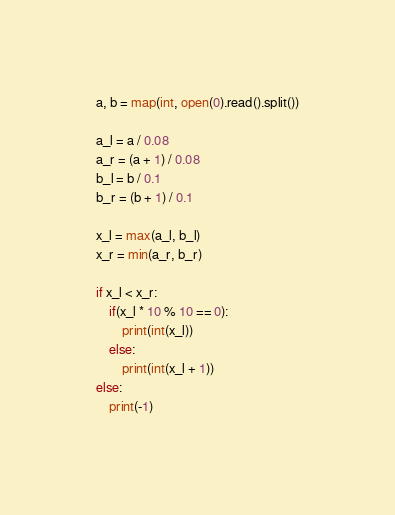<code> <loc_0><loc_0><loc_500><loc_500><_Python_>a, b = map(int, open(0).read().split())

a_l = a / 0.08
a_r = (a + 1) / 0.08
b_l = b / 0.1
b_r = (b + 1) / 0.1

x_l = max(a_l, b_l)
x_r = min(a_r, b_r)

if x_l < x_r:
    if(x_l * 10 % 10 == 0):
        print(int(x_l))
    else:
        print(int(x_l + 1))
else:
    print(-1)</code> 